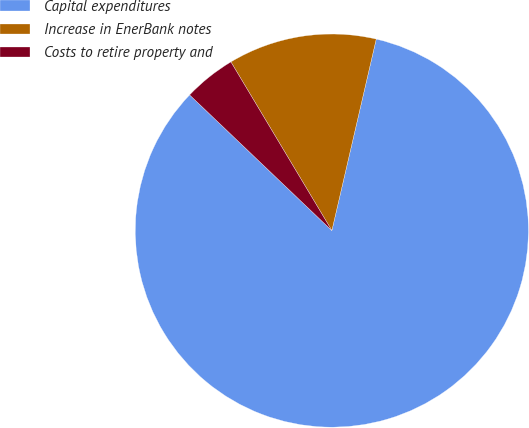Convert chart to OTSL. <chart><loc_0><loc_0><loc_500><loc_500><pie_chart><fcel>Capital expenditures<fcel>Increase in EnerBank notes<fcel>Costs to retire property and<nl><fcel>83.51%<fcel>12.21%<fcel>4.29%<nl></chart> 